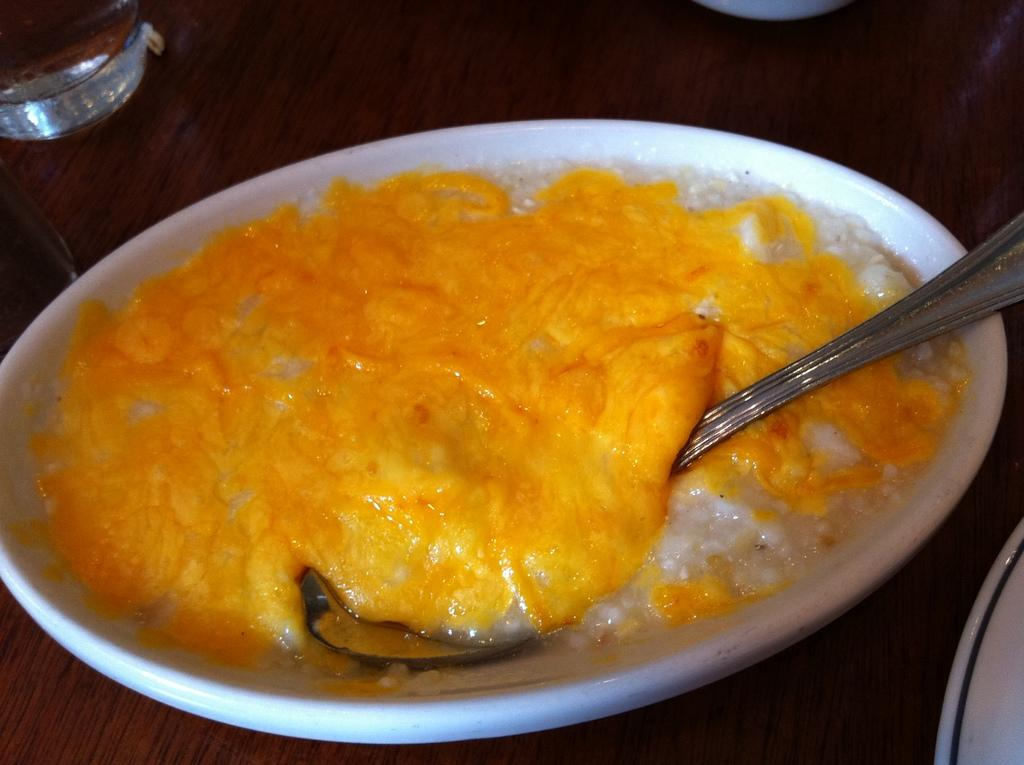What is on the wooden surface in the image? There is a bowl on the wooden surface. What is inside the bowl? The bowl contains a spoon and food. Can you describe the dish in the image? There is a dish in the top left of the image. Where is the mom in the image? There is no mom present in the image. What type of bushes can be seen in the image? There are no bushes visible in the image. 